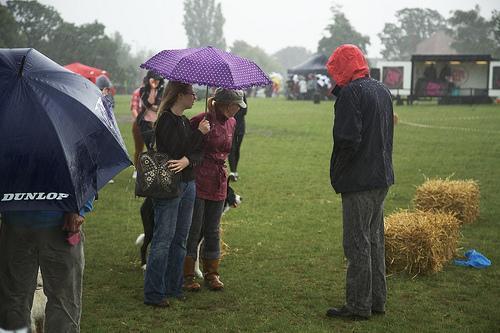How many umbrellas are in the photo?
Give a very brief answer. 2. How many people are standing under the polka dot umbrella?
Give a very brief answer. 2. 